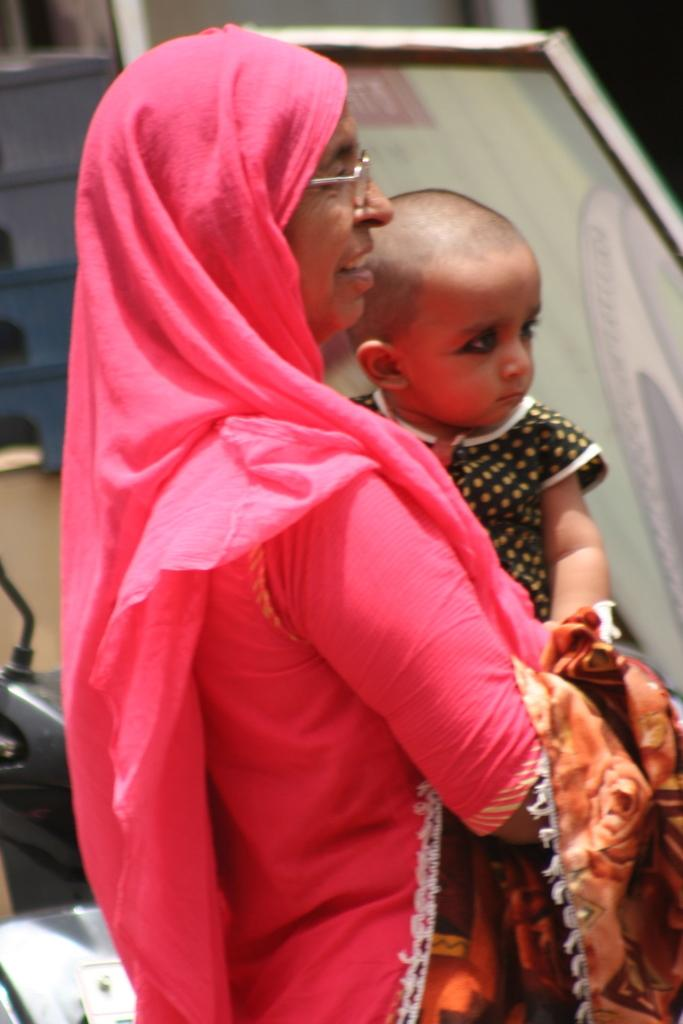What is the main subject of the image? There is a woman standing in the image. What is the woman doing in the image? The woman is carrying a baby in her baby in her hands. In which direction is the woman facing? The woman is facing towards the right side. What can be seen in the background of the image? There is a board visible in the background of the image. What type of steel is used to construct the needle in the image? There is no steel or needle present in the image. What curve can be seen in the image? There is no curve visible in the image. 